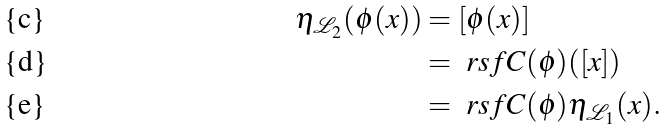<formula> <loc_0><loc_0><loc_500><loc_500>\eta _ { \mathcal { L } _ { 2 } } ( \phi ( x ) ) & = [ \phi ( x ) ] \\ & = \ r s f C ( \phi ) ( [ x ] ) \\ & = \ r s f C ( \phi ) \eta _ { \mathcal { L } _ { 1 } } ( x ) .</formula> 